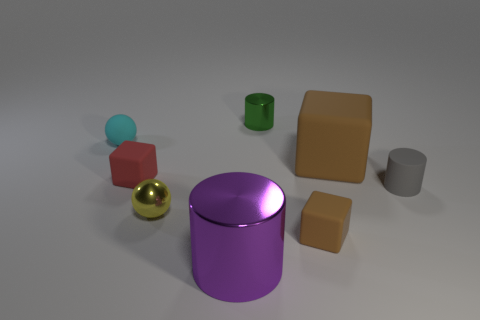What is the color of the other tiny object that is the same shape as the cyan thing? The tiny object sharing the same cylindrical shape as the cyan one is colored gold. 